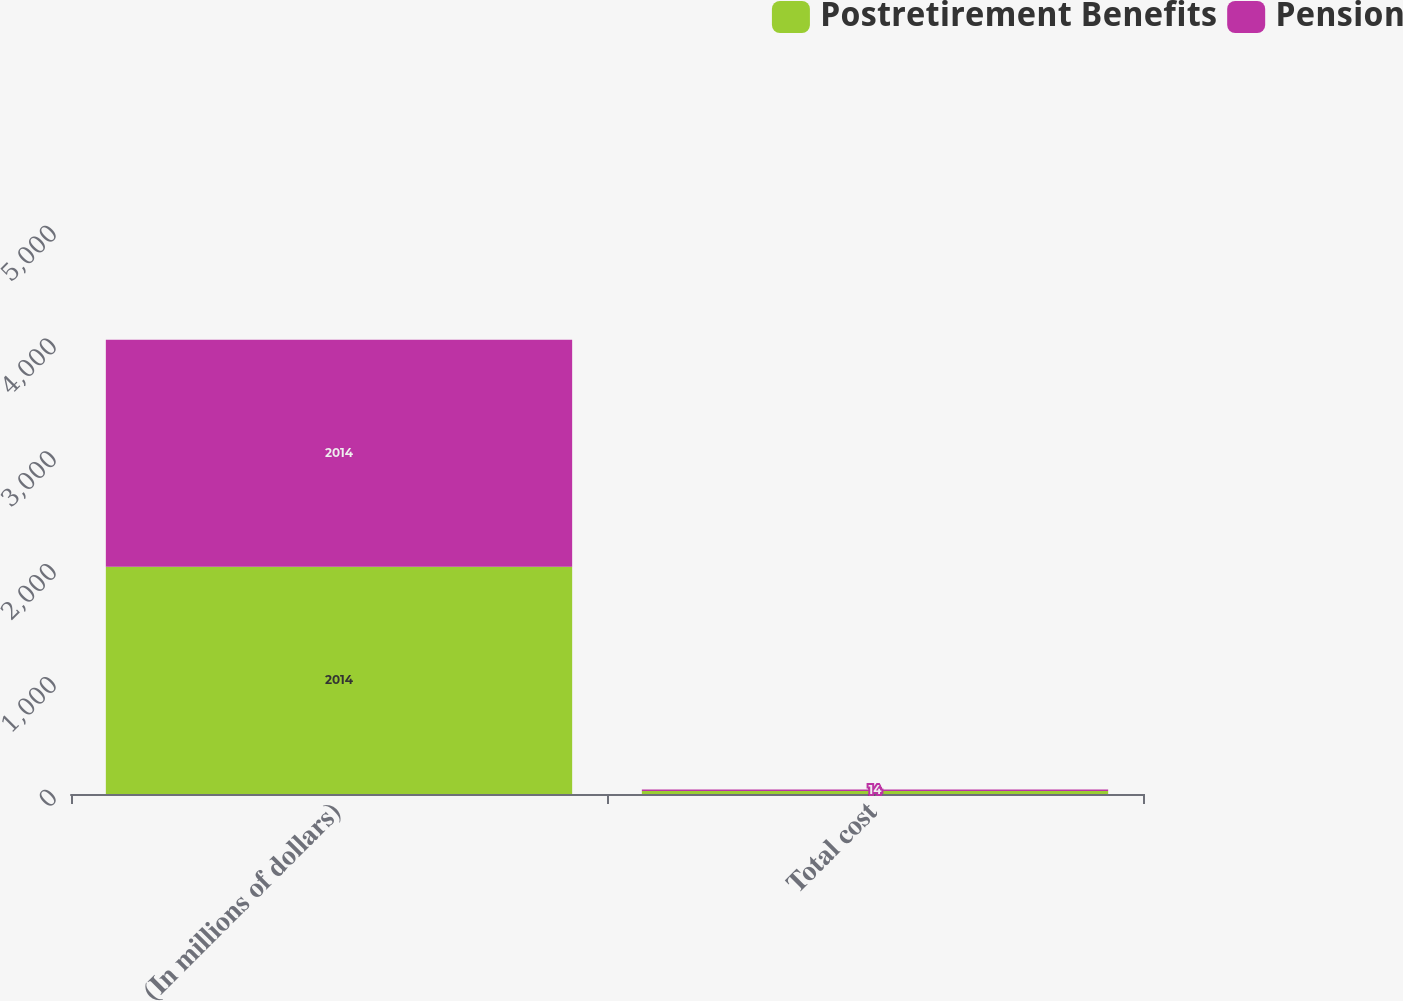<chart> <loc_0><loc_0><loc_500><loc_500><stacked_bar_chart><ecel><fcel>(In millions of dollars)<fcel>Total cost<nl><fcel>Postretirement Benefits<fcel>2014<fcel>26<nl><fcel>Pension<fcel>2014<fcel>14<nl></chart> 